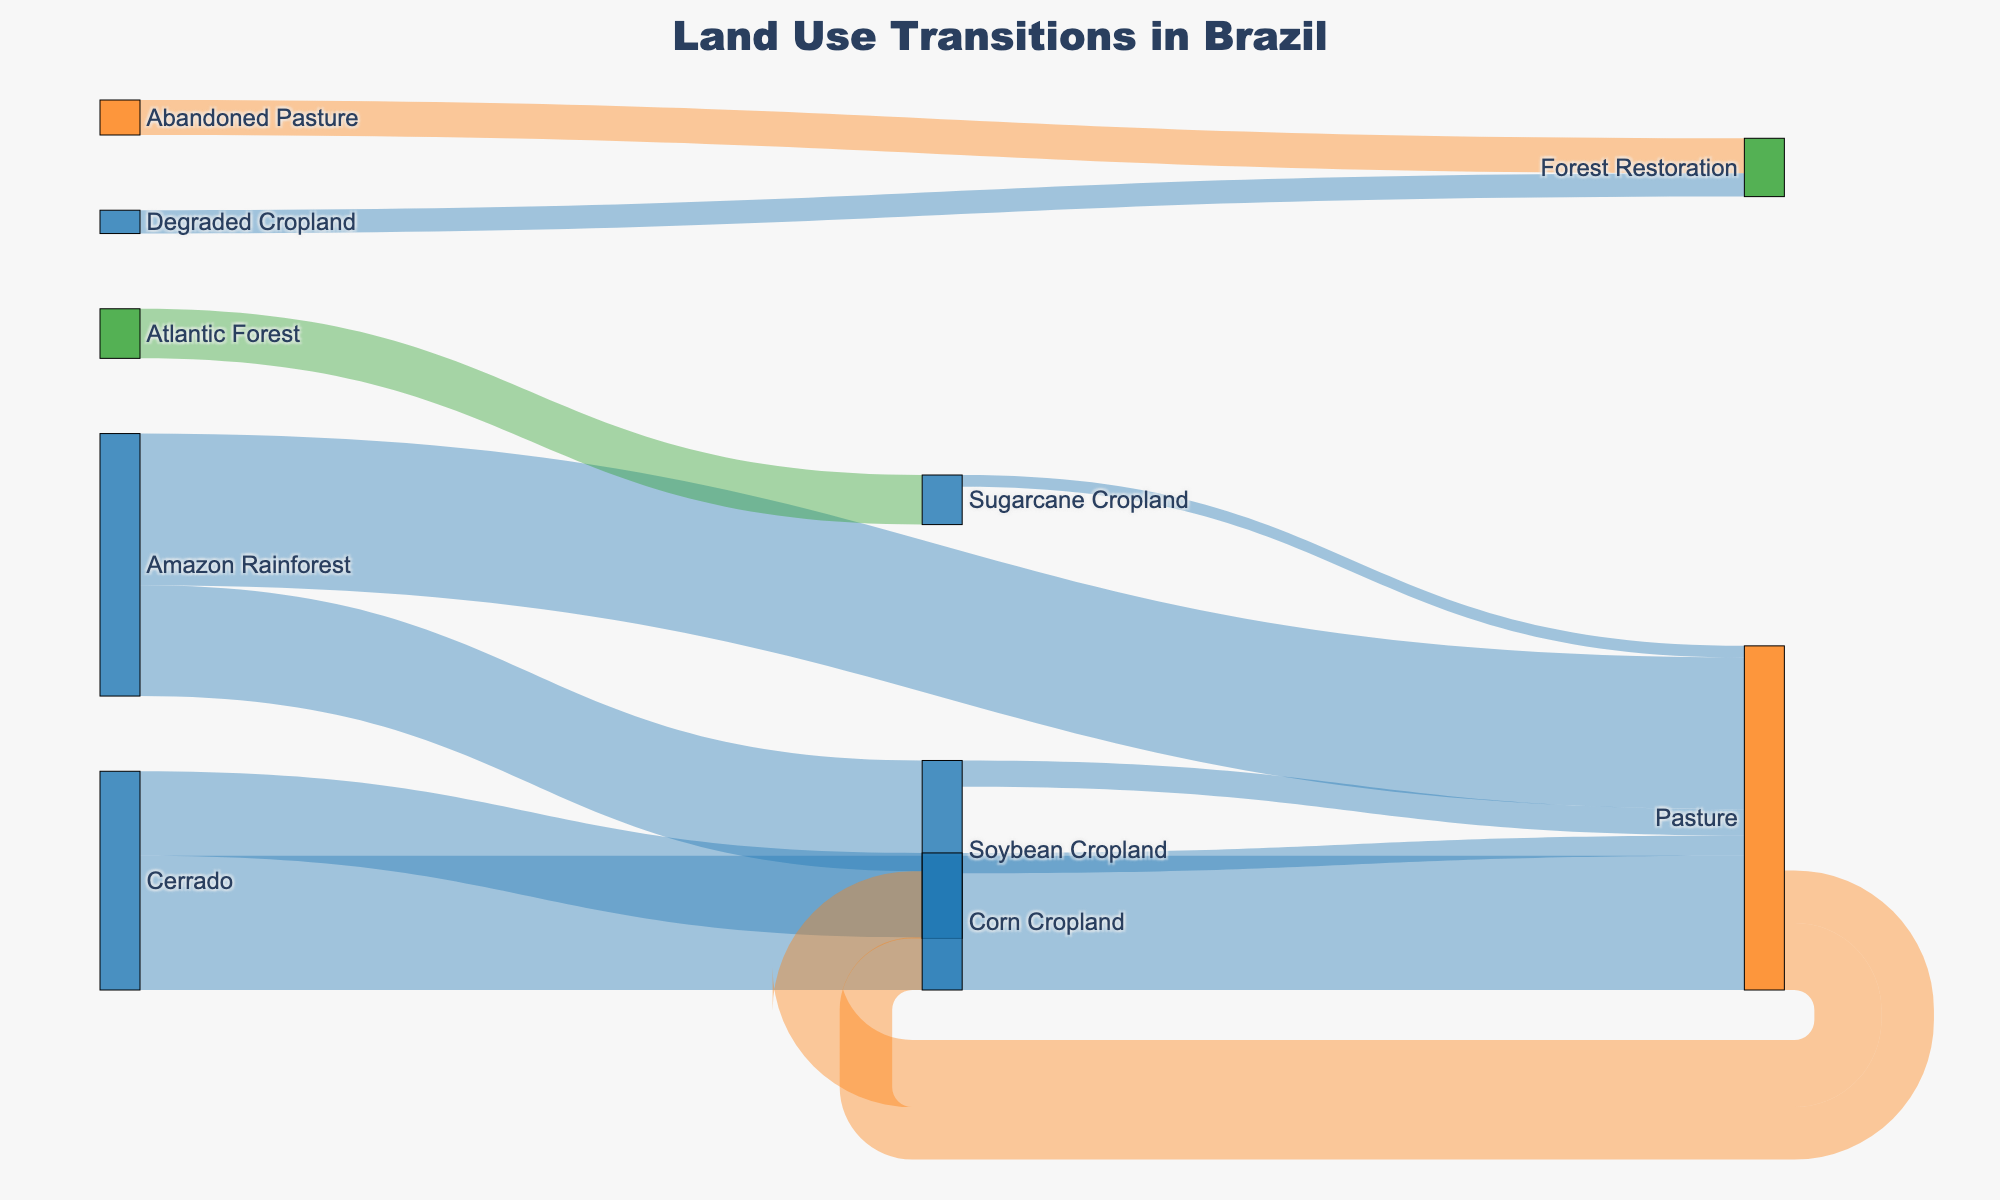What transitions does the Amazon Rainforest undergo in the figure? The transitions involving the Amazon Rainforest are from the Amazon Rainforest to Pasture and from the Amazon Rainforest to Soybean Cropland. These transitions are represented by links originating from the Amazon Rainforest node and connecting to the Pasture and Soybean Cropland nodes.
Answer: Pasture, Soybean Cropland What is the total value of land use transition from Forest sources? To find the total value, sum up all transitions originating from any kind of forest: Amazon Rainforest to Pasture (5.2), Amazon Rainforest to Soybean Cropland (3.8), Atlantic Forest to Sugarcane Cropland (1.7), Abandoned Pasture to Forest Restoration (1.2), and Degraded Cropland to Forest Restoration (0.8). Hence, 5.2 + 3.8 + 1.7 + 1.2 + 0.8 = 12.7.
Answer: 12.7 Which has a higher transition value: Corn Cropland to Pasture or Soybean Cropland to Pasture? Comparing the values for the transitions, Corn Cropland to Pasture is 0.7, and Soybean Cropland to Pasture is 0.9. Since 0.9 is greater than 0.7, the transition from Soybean Cropland to Pasture has a higher value.
Answer: Soybean Cropland to Pasture How much land transitions directly to Soybean Cropland in total? To determine the total land transition to Soybean Cropland, sum the values from Amazon Rainforest to Soybean Cropland (3.8) and Pasture to Soybean Cropland (2.3). Hence, 3.8 + 2.3 = 6.1.
Answer: 6.1 What is the difference in land transition value between Pasture to Corn Cropland and Pasture to Soybean Cropland? The value for Pasture to Corn Cropland is 1.8 and for Pasture to Soybean Cropland is 2.3. The difference is calculated by subtracting 1.8 from 2.3, resulting in 2.3 - 1.8 = 0.5.
Answer: 0.5 Which has a greater transition aggregate: Cropland to Pasture or any transition involving Forest? Summing up transitions to Pasture from Soybean Cropland (0.9), Corn Cropland (0.7), and Sugarcane Cropland (0.4), the total is 0.9 + 0.7 + 0.4 = 2.0. Summing all transitions involving Forest sources: Amazon Rainforest to Pasture (5.2), Amazon Rainforest to Soybean Cropland (3.8), Atlantic Forest to Sugarcane Cropland (1.7), Abandoned Pasture to Forest Restoration (1.2), Degraded Cropland to Forest Restoration (0.8), the total is 5.2 + 3.8 + 1.7 + 1.2 + 0.8 = 12.7. Therefore, any transition involving Forest has a greater aggregate.
Answer: Any transition involving Forest Which transition involving Pasture as the source has the highest value? Referring to transitions from Pasture, which are Pasture to Soybean Cropland (2.3) and Pasture to Corn Cropland (1.8), it is clear that the transition to Soybean Cropland has the higher value.
Answer: Pasture to Soybean Cropland 